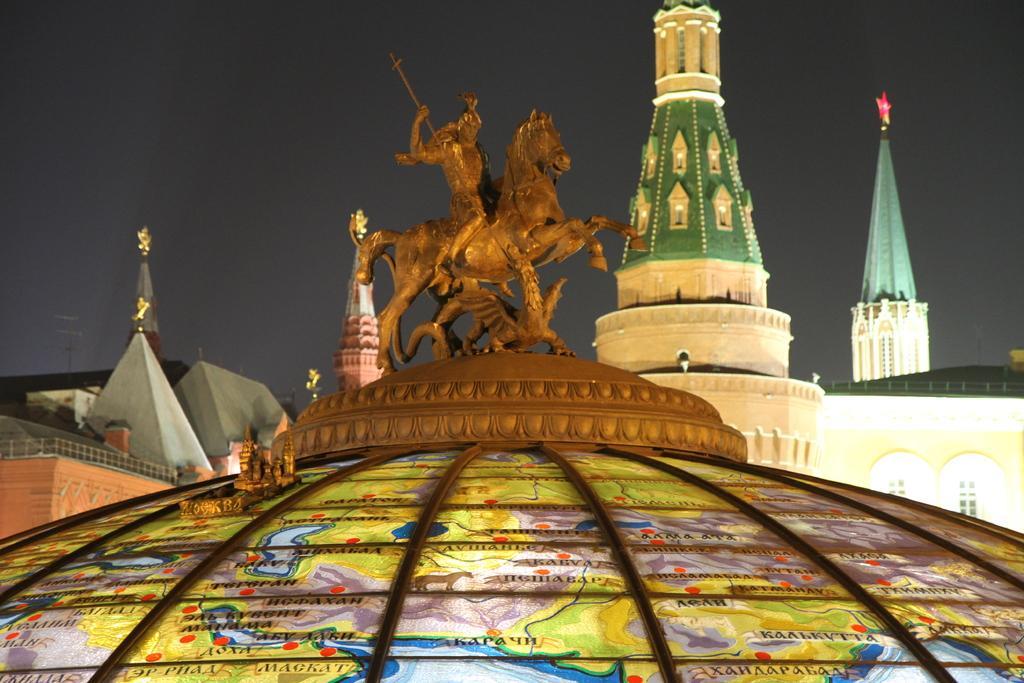Can you describe this image briefly? In the foreground of the picture there is a sculpture on the dome of a building. In the middle of the picture there are buildings. At the top there is sky. 